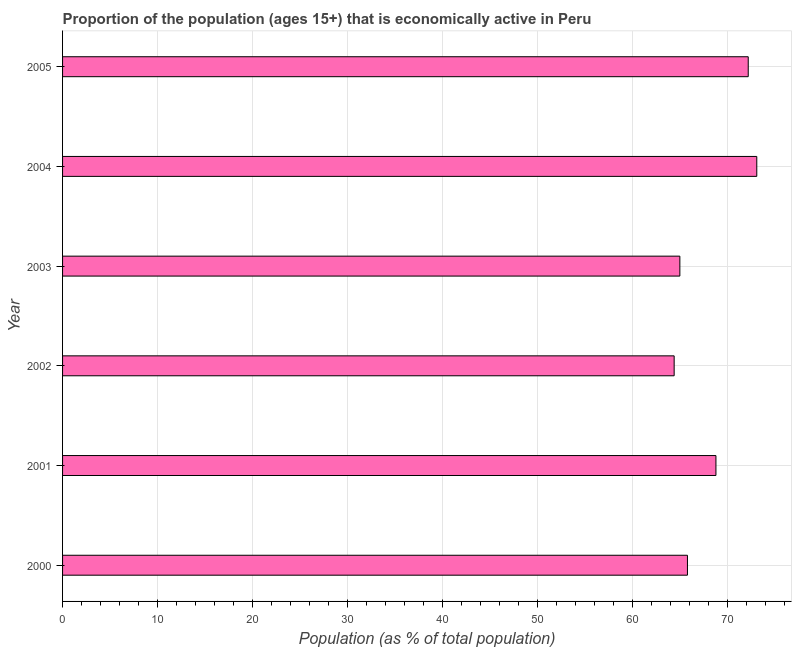Does the graph contain any zero values?
Ensure brevity in your answer.  No. What is the title of the graph?
Offer a terse response. Proportion of the population (ages 15+) that is economically active in Peru. What is the label or title of the X-axis?
Give a very brief answer. Population (as % of total population). What is the percentage of economically active population in 2000?
Provide a succinct answer. 65.8. Across all years, what is the maximum percentage of economically active population?
Offer a very short reply. 73.1. Across all years, what is the minimum percentage of economically active population?
Provide a succinct answer. 64.4. In which year was the percentage of economically active population maximum?
Keep it short and to the point. 2004. What is the sum of the percentage of economically active population?
Offer a terse response. 409.3. What is the average percentage of economically active population per year?
Ensure brevity in your answer.  68.22. What is the median percentage of economically active population?
Your answer should be very brief. 67.3. Do a majority of the years between 2002 and 2001 (inclusive) have percentage of economically active population greater than 10 %?
Provide a succinct answer. No. What is the ratio of the percentage of economically active population in 2002 to that in 2004?
Offer a very short reply. 0.88. Is the percentage of economically active population in 2001 less than that in 2002?
Your response must be concise. No. Is the difference between the percentage of economically active population in 2001 and 2002 greater than the difference between any two years?
Provide a succinct answer. No. Is the sum of the percentage of economically active population in 2000 and 2005 greater than the maximum percentage of economically active population across all years?
Keep it short and to the point. Yes. What is the difference between the highest and the lowest percentage of economically active population?
Offer a very short reply. 8.7. How many bars are there?
Provide a short and direct response. 6. Are all the bars in the graph horizontal?
Your response must be concise. Yes. Are the values on the major ticks of X-axis written in scientific E-notation?
Your response must be concise. No. What is the Population (as % of total population) of 2000?
Provide a succinct answer. 65.8. What is the Population (as % of total population) in 2001?
Your response must be concise. 68.8. What is the Population (as % of total population) of 2002?
Keep it short and to the point. 64.4. What is the Population (as % of total population) in 2004?
Give a very brief answer. 73.1. What is the Population (as % of total population) of 2005?
Provide a short and direct response. 72.2. What is the difference between the Population (as % of total population) in 2000 and 2002?
Offer a terse response. 1.4. What is the difference between the Population (as % of total population) in 2000 and 2005?
Offer a very short reply. -6.4. What is the difference between the Population (as % of total population) in 2001 and 2002?
Your response must be concise. 4.4. What is the difference between the Population (as % of total population) in 2001 and 2003?
Your answer should be compact. 3.8. What is the difference between the Population (as % of total population) in 2001 and 2005?
Your answer should be compact. -3.4. What is the difference between the Population (as % of total population) in 2002 and 2004?
Ensure brevity in your answer.  -8.7. What is the difference between the Population (as % of total population) in 2003 and 2005?
Keep it short and to the point. -7.2. What is the ratio of the Population (as % of total population) in 2000 to that in 2001?
Your response must be concise. 0.96. What is the ratio of the Population (as % of total population) in 2000 to that in 2004?
Ensure brevity in your answer.  0.9. What is the ratio of the Population (as % of total population) in 2000 to that in 2005?
Your response must be concise. 0.91. What is the ratio of the Population (as % of total population) in 2001 to that in 2002?
Offer a terse response. 1.07. What is the ratio of the Population (as % of total population) in 2001 to that in 2003?
Your response must be concise. 1.06. What is the ratio of the Population (as % of total population) in 2001 to that in 2004?
Keep it short and to the point. 0.94. What is the ratio of the Population (as % of total population) in 2001 to that in 2005?
Provide a short and direct response. 0.95. What is the ratio of the Population (as % of total population) in 2002 to that in 2004?
Offer a terse response. 0.88. What is the ratio of the Population (as % of total population) in 2002 to that in 2005?
Keep it short and to the point. 0.89. What is the ratio of the Population (as % of total population) in 2003 to that in 2004?
Your answer should be compact. 0.89. What is the ratio of the Population (as % of total population) in 2003 to that in 2005?
Make the answer very short. 0.9. 